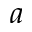Convert formula to latex. <formula><loc_0><loc_0><loc_500><loc_500>a</formula> 